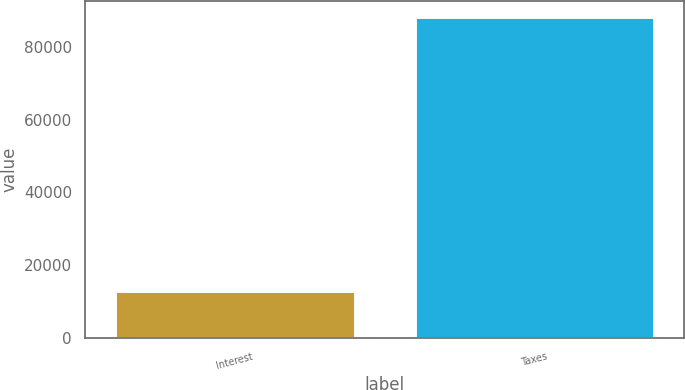Convert chart. <chart><loc_0><loc_0><loc_500><loc_500><bar_chart><fcel>Interest<fcel>Taxes<nl><fcel>12922<fcel>88277<nl></chart> 